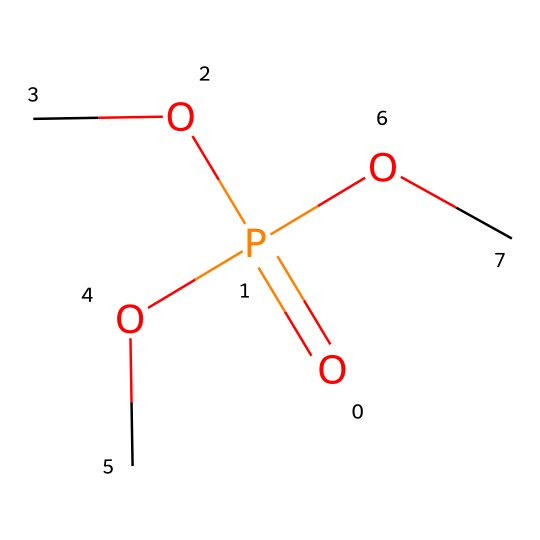What is the molecular formula of this compound? The compound consists of one phosphorus atom (P), four oxygen atoms (O), and six carbon atoms (C) derived from the three methoxy groups (OC) and the central phosphorus atom. Thus, the molecular formula is C6H15O4P.
Answer: C6H15O4P How many oxygen atoms are in the structure? Observing the structure, there are four oxygen atoms present—three from the methoxy groups and one from the phosphorus group.
Answer: 4 What is the central atom in this compound? Looking at the structure, the atom that connects the three methoxy groups is phosphorus, making it the central atom in this compound.
Answer: phosphorus Is this compound likely to be soluble in water? The presence of multiple polar methoxy groups suggests that the compound has potential water solubility; hence, it is likely to be soluble in water.
Answer: yes What type of chemical bond primarily connects the carbon and oxygen in this compound? The bonds connecting carbon (C) and oxygen (O) in methoxy groups are covalent bonds, which are typical in organic compounds where atoms share electrons.
Answer: covalent In terms of flame-retardant efficiency, how many functional groups are used in this structure? Each methoxy group acts as a functional group contributing to flame retardancy; there are three methoxy groups, making three functional groups in total.
Answer: 3 